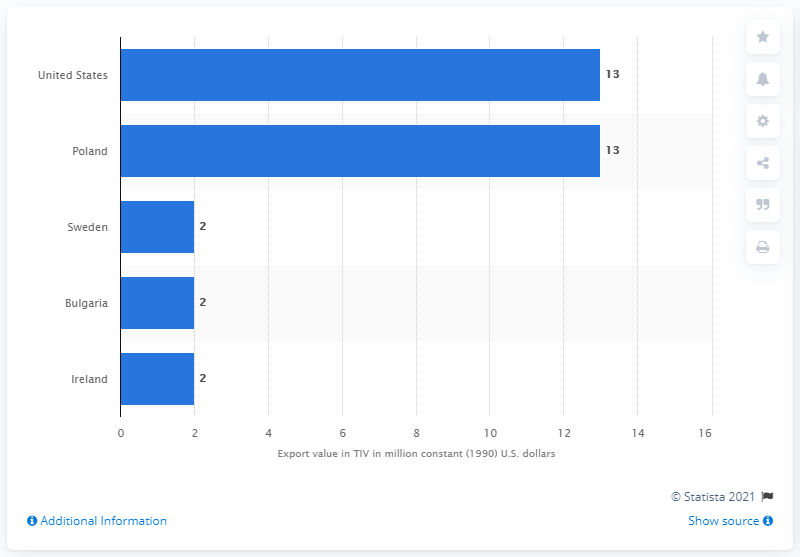Specify some key components in this picture. In 2019, the United States received a total of 13 constant U.S. dollars worth of arms exports from Norway. 